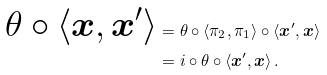<formula> <loc_0><loc_0><loc_500><loc_500>\theta \circ \langle \boldsymbol x , \boldsymbol x ^ { \prime } \rangle & = \theta \circ \langle \pi _ { 2 } , \pi _ { 1 } \rangle \circ \langle \boldsymbol x ^ { \prime } , \boldsymbol x \rangle \\ & = i \circ \theta \circ \langle \boldsymbol x ^ { \prime } , \boldsymbol x \rangle \, .</formula> 